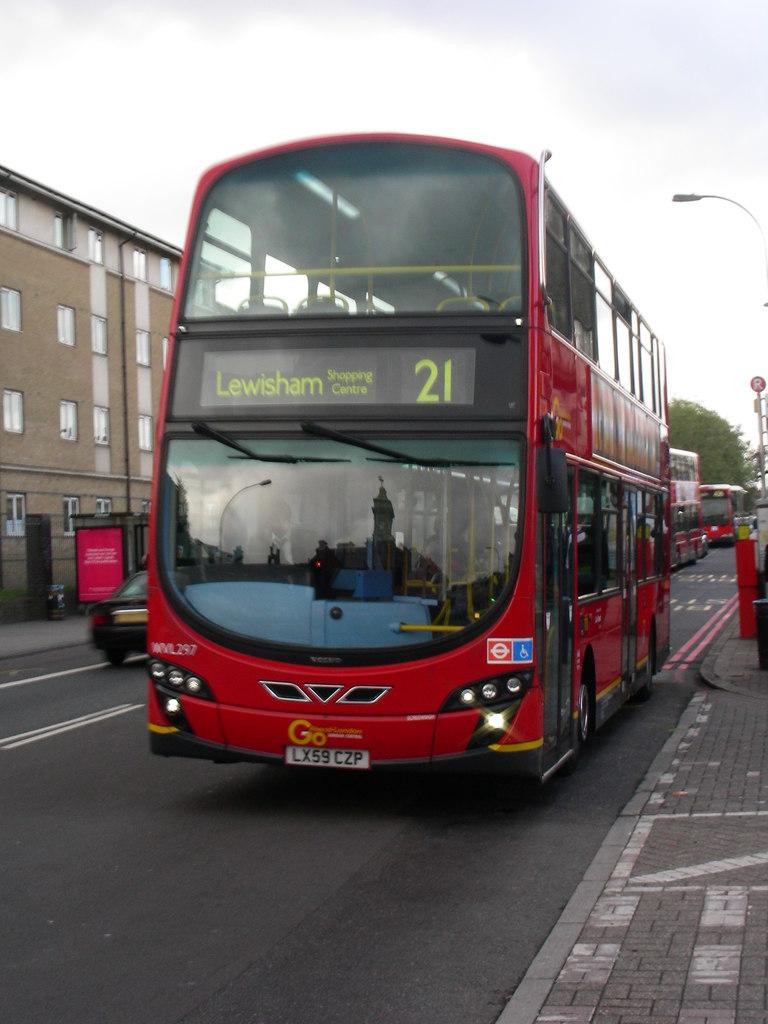Where is the bus headed?
Provide a succinct answer. Lewisham. What number is the bus, or what number is its stop?
Make the answer very short. 21. 